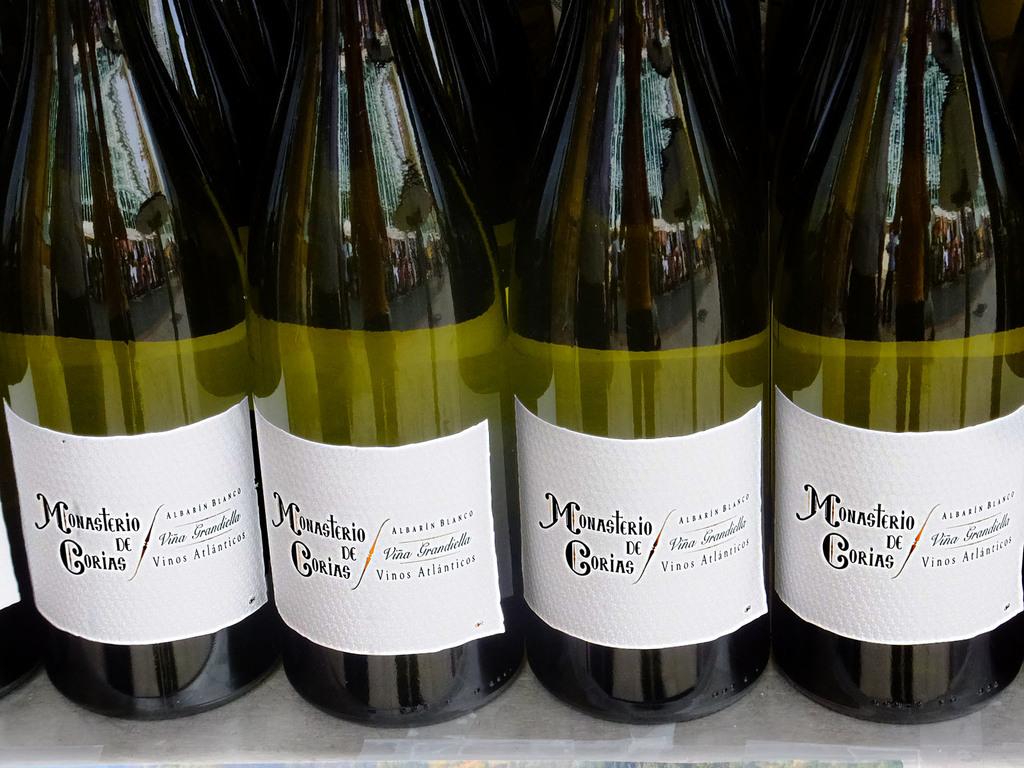What brand is this wine?
Your response must be concise. Monasterio de corias. 